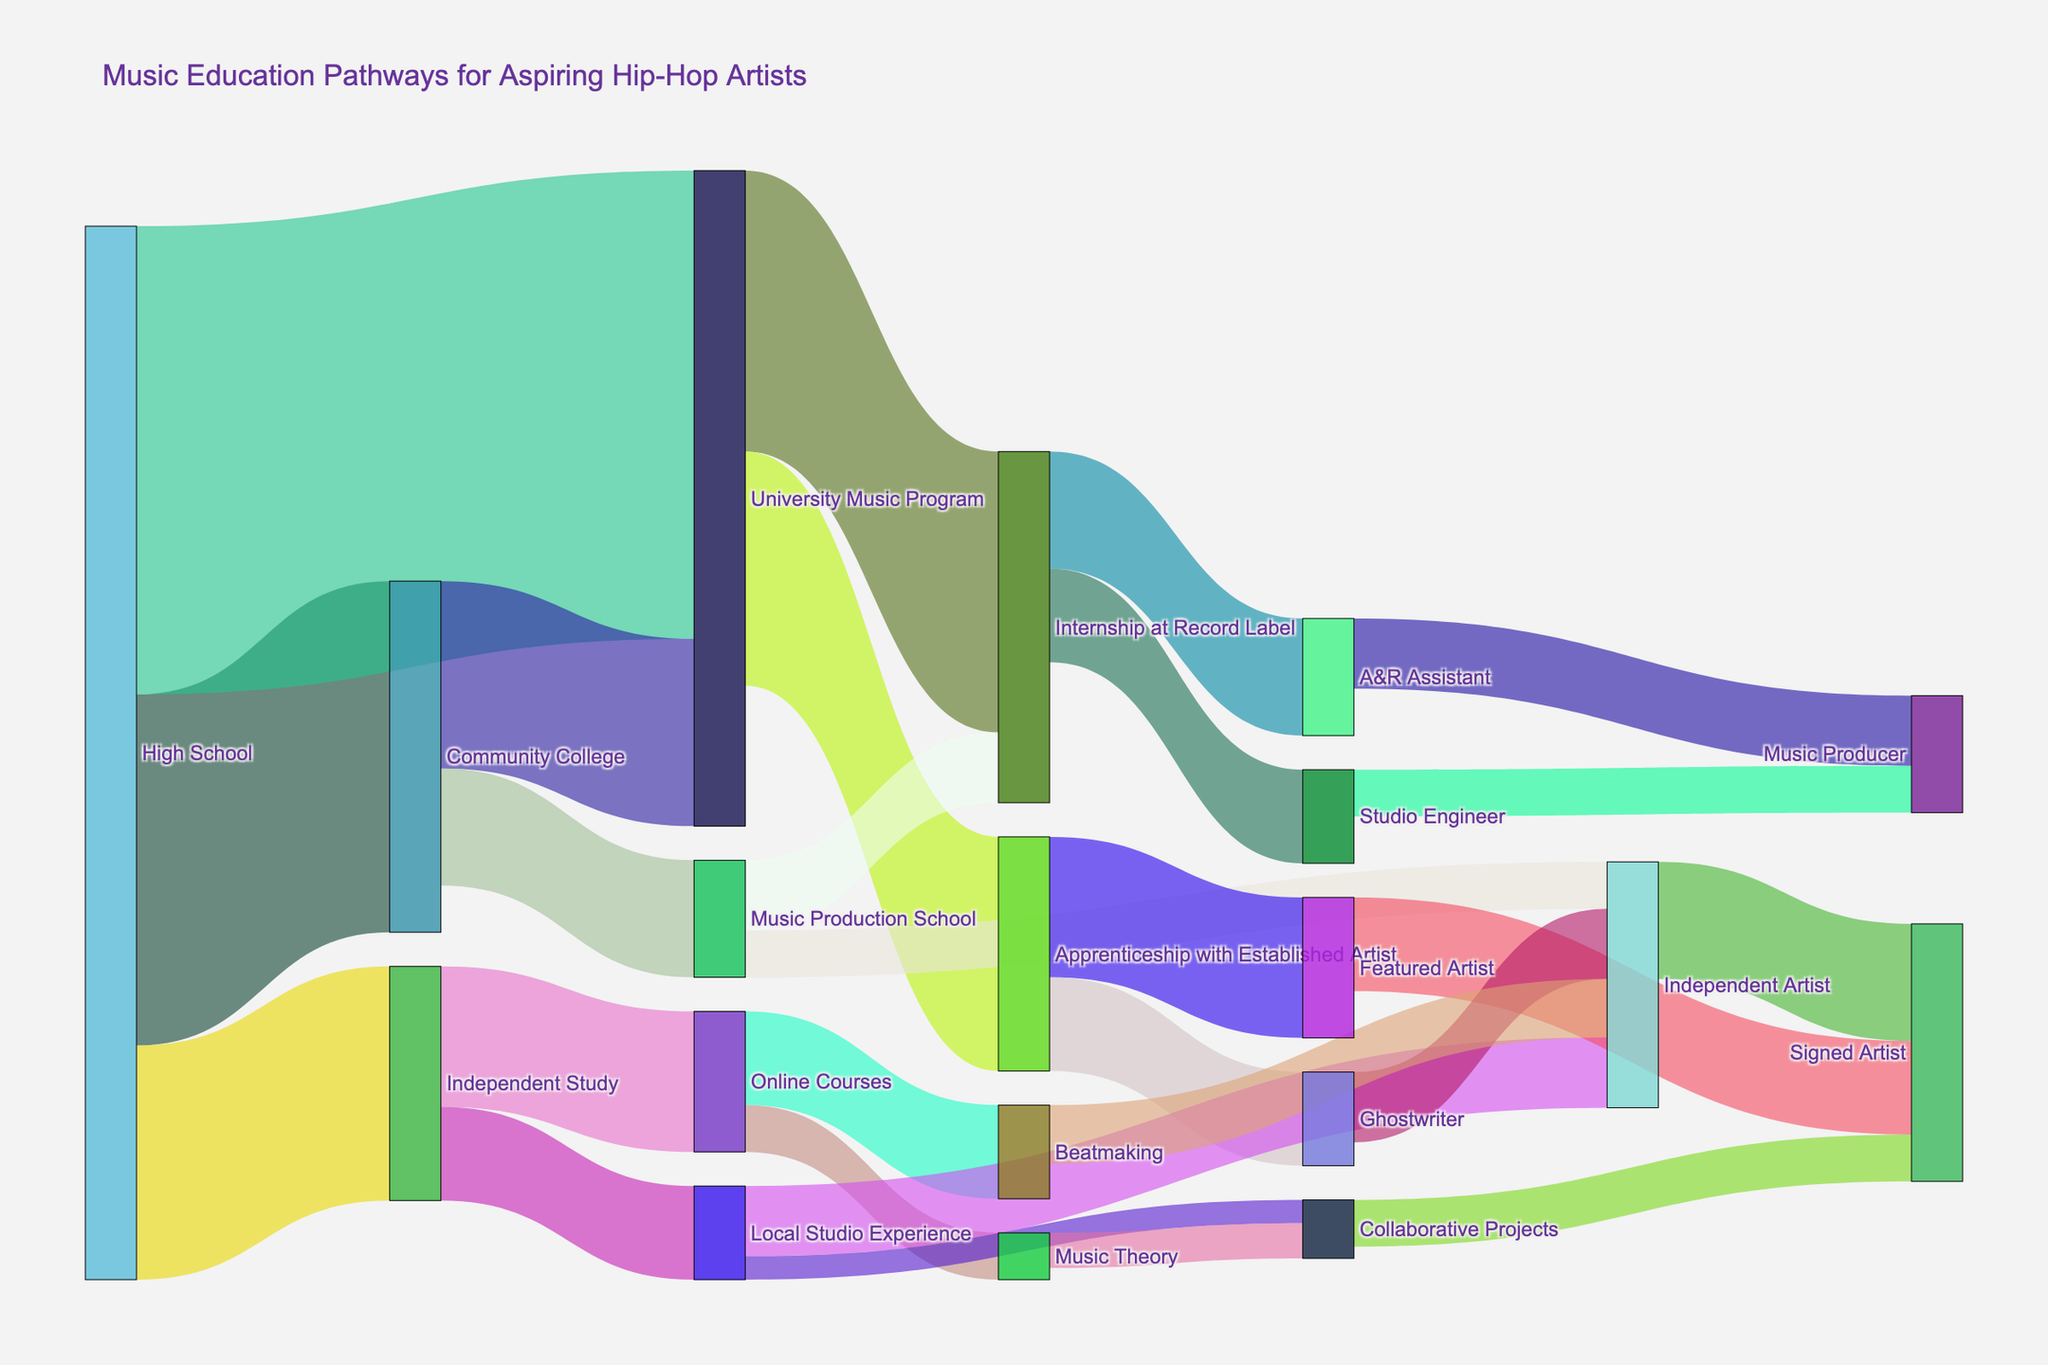what is the title of the figure? The title of the figure is usually placed at the top and prominently displayed. In this Sankey Diagram, it states "Music Education Pathways for Aspiring Hip-Hop Artists."
Answer: Music Education Pathways for Aspiring Hip-Hop Artists how many pathways originate from high school? To answer this, look at how many links or connections start from the "High School" node and branch out to other nodes. There are three pathways: Community College, University Music Program, and Independent Study.
Answer: 3 how many people transitioned from community college to university music program? Find the flow originating from "Community College" and ending at "University Music Program." The value associated with this flow is 80.
Answer: 80 what pathways lead to the role of a music producer? Identify the nodes/flows that end at the "Music Producer" node. These pathways are from "A&R Assistant" and "Studio Engineer."
Answer: A&R Assistant, Studio Engineer which pathway has the highest number transitioning directly from high school? Analyze the values associated with pathways originating from "High School." The highest number here is from "High School" to "University Music Program," which has a value of 200.
Answer: University Music Program how many people became signed artists? To find this, sum up all the values leading to the "Signed Artist" node. These pathways and their respective values are from "Featured Artist" (40), "Independent Artist" (50), and "Collaborative Projects" (20). Hence, the sum is 40 + 50 + 20 = 110.
Answer: 110 what is the total number of people who pursued independent study? Look at the values associated with the flows originating from "Independent Study." The pathways are to "Online Courses" (60) and "Local Studio Experience" (40). The total is 60 + 40 = 100.
Answer: 100 are there more people who pursued an internship at a record label from university music program or music production school? Compare the flow values from "University Music Program" (120) and "Music Production School" (30) leading to "Internship at Record Label." The University Music Program has more with 120.
Answer: University Music Program which pathway did the largest number of people take from independent study? Observe the flows from "Independent Study." The values are "Online Courses" (60) and "Local Studio Experience" (40). The largest is "Online Courses" with 60.
Answer: Online Courses how many people pursued a community college pathway and then went to music production school? Find the flow from "Community College" to "Music Production School," which has a value of 50.
Answer: 50 